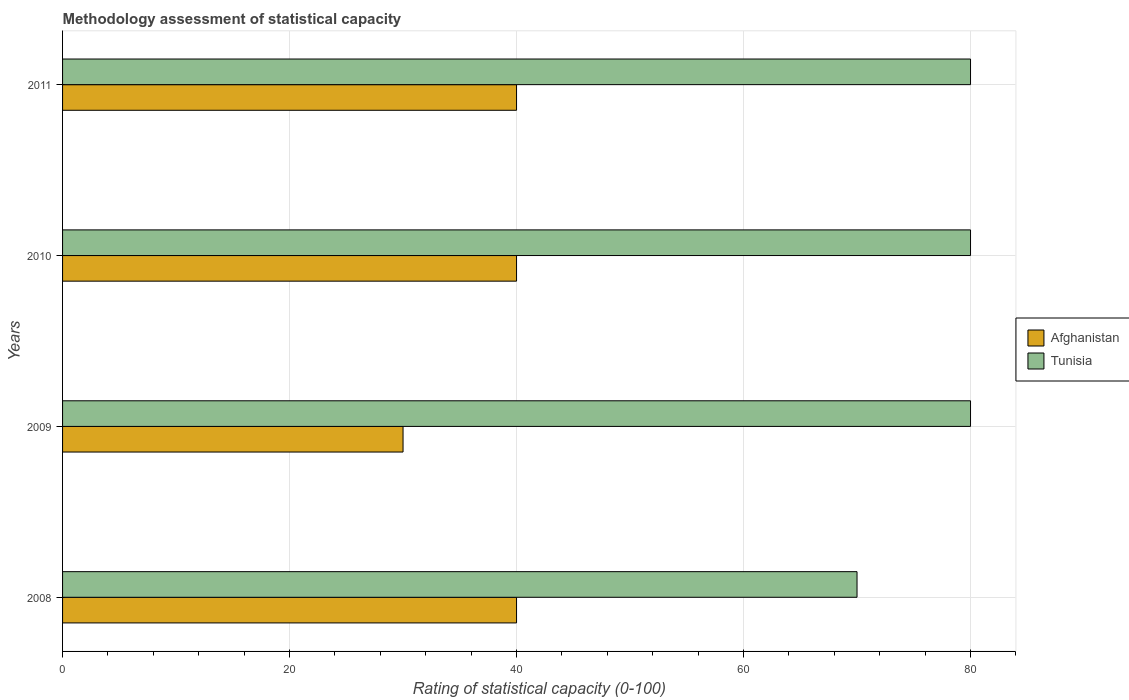How many different coloured bars are there?
Your answer should be compact. 2. Are the number of bars on each tick of the Y-axis equal?
Your answer should be compact. Yes. How many bars are there on the 1st tick from the top?
Offer a very short reply. 2. How many bars are there on the 3rd tick from the bottom?
Provide a succinct answer. 2. What is the label of the 1st group of bars from the top?
Offer a terse response. 2011. In how many cases, is the number of bars for a given year not equal to the number of legend labels?
Offer a very short reply. 0. What is the rating of statistical capacity in Afghanistan in 2009?
Provide a succinct answer. 30. Across all years, what is the maximum rating of statistical capacity in Afghanistan?
Ensure brevity in your answer.  40. Across all years, what is the minimum rating of statistical capacity in Tunisia?
Your response must be concise. 70. In which year was the rating of statistical capacity in Tunisia maximum?
Ensure brevity in your answer.  2009. What is the total rating of statistical capacity in Tunisia in the graph?
Your answer should be compact. 310. What is the difference between the rating of statistical capacity in Tunisia in 2008 and that in 2010?
Offer a very short reply. -10. What is the difference between the rating of statistical capacity in Tunisia in 2010 and the rating of statistical capacity in Afghanistan in 2009?
Provide a succinct answer. 50. What is the average rating of statistical capacity in Afghanistan per year?
Provide a succinct answer. 37.5. In the year 2010, what is the difference between the rating of statistical capacity in Afghanistan and rating of statistical capacity in Tunisia?
Provide a short and direct response. -40. In how many years, is the rating of statistical capacity in Afghanistan greater than 64 ?
Provide a succinct answer. 0. Is the rating of statistical capacity in Tunisia in 2008 less than that in 2011?
Your response must be concise. Yes. What is the difference between the highest and the lowest rating of statistical capacity in Tunisia?
Ensure brevity in your answer.  10. Is the sum of the rating of statistical capacity in Afghanistan in 2010 and 2011 greater than the maximum rating of statistical capacity in Tunisia across all years?
Provide a short and direct response. No. What does the 1st bar from the top in 2011 represents?
Provide a succinct answer. Tunisia. What does the 2nd bar from the bottom in 2011 represents?
Your answer should be very brief. Tunisia. Are all the bars in the graph horizontal?
Provide a short and direct response. Yes. What is the difference between two consecutive major ticks on the X-axis?
Offer a very short reply. 20. Does the graph contain any zero values?
Your response must be concise. No. Where does the legend appear in the graph?
Give a very brief answer. Center right. How many legend labels are there?
Your answer should be very brief. 2. How are the legend labels stacked?
Keep it short and to the point. Vertical. What is the title of the graph?
Ensure brevity in your answer.  Methodology assessment of statistical capacity. What is the label or title of the X-axis?
Your answer should be very brief. Rating of statistical capacity (0-100). What is the label or title of the Y-axis?
Your answer should be compact. Years. What is the Rating of statistical capacity (0-100) of Tunisia in 2008?
Offer a very short reply. 70. What is the Rating of statistical capacity (0-100) of Tunisia in 2009?
Offer a very short reply. 80. What is the Rating of statistical capacity (0-100) in Afghanistan in 2010?
Make the answer very short. 40. Across all years, what is the maximum Rating of statistical capacity (0-100) in Afghanistan?
Offer a terse response. 40. Across all years, what is the minimum Rating of statistical capacity (0-100) of Afghanistan?
Offer a very short reply. 30. Across all years, what is the minimum Rating of statistical capacity (0-100) in Tunisia?
Keep it short and to the point. 70. What is the total Rating of statistical capacity (0-100) in Afghanistan in the graph?
Your answer should be very brief. 150. What is the total Rating of statistical capacity (0-100) in Tunisia in the graph?
Provide a short and direct response. 310. What is the difference between the Rating of statistical capacity (0-100) of Afghanistan in 2008 and that in 2010?
Offer a terse response. 0. What is the difference between the Rating of statistical capacity (0-100) of Tunisia in 2008 and that in 2011?
Ensure brevity in your answer.  -10. What is the difference between the Rating of statistical capacity (0-100) in Afghanistan in 2009 and that in 2010?
Your answer should be compact. -10. What is the difference between the Rating of statistical capacity (0-100) of Tunisia in 2009 and that in 2010?
Your answer should be compact. 0. What is the difference between the Rating of statistical capacity (0-100) of Tunisia in 2009 and that in 2011?
Offer a very short reply. 0. What is the difference between the Rating of statistical capacity (0-100) in Afghanistan in 2010 and that in 2011?
Provide a short and direct response. 0. What is the difference between the Rating of statistical capacity (0-100) in Tunisia in 2010 and that in 2011?
Ensure brevity in your answer.  0. What is the difference between the Rating of statistical capacity (0-100) in Afghanistan in 2008 and the Rating of statistical capacity (0-100) in Tunisia in 2010?
Ensure brevity in your answer.  -40. What is the difference between the Rating of statistical capacity (0-100) in Afghanistan in 2009 and the Rating of statistical capacity (0-100) in Tunisia in 2010?
Ensure brevity in your answer.  -50. What is the difference between the Rating of statistical capacity (0-100) of Afghanistan in 2009 and the Rating of statistical capacity (0-100) of Tunisia in 2011?
Offer a very short reply. -50. What is the average Rating of statistical capacity (0-100) in Afghanistan per year?
Your answer should be very brief. 37.5. What is the average Rating of statistical capacity (0-100) in Tunisia per year?
Your answer should be very brief. 77.5. In the year 2008, what is the difference between the Rating of statistical capacity (0-100) of Afghanistan and Rating of statistical capacity (0-100) of Tunisia?
Provide a succinct answer. -30. In the year 2009, what is the difference between the Rating of statistical capacity (0-100) in Afghanistan and Rating of statistical capacity (0-100) in Tunisia?
Provide a short and direct response. -50. In the year 2010, what is the difference between the Rating of statistical capacity (0-100) of Afghanistan and Rating of statistical capacity (0-100) of Tunisia?
Ensure brevity in your answer.  -40. What is the ratio of the Rating of statistical capacity (0-100) of Tunisia in 2008 to that in 2009?
Give a very brief answer. 0.88. What is the ratio of the Rating of statistical capacity (0-100) in Tunisia in 2008 to that in 2010?
Give a very brief answer. 0.88. What is the ratio of the Rating of statistical capacity (0-100) in Afghanistan in 2008 to that in 2011?
Your answer should be compact. 1. What is the ratio of the Rating of statistical capacity (0-100) of Afghanistan in 2009 to that in 2011?
Give a very brief answer. 0.75. What is the ratio of the Rating of statistical capacity (0-100) in Tunisia in 2009 to that in 2011?
Offer a terse response. 1. What is the difference between the highest and the second highest Rating of statistical capacity (0-100) in Afghanistan?
Ensure brevity in your answer.  0. What is the difference between the highest and the second highest Rating of statistical capacity (0-100) in Tunisia?
Keep it short and to the point. 0. What is the difference between the highest and the lowest Rating of statistical capacity (0-100) of Afghanistan?
Your response must be concise. 10. What is the difference between the highest and the lowest Rating of statistical capacity (0-100) in Tunisia?
Your answer should be very brief. 10. 